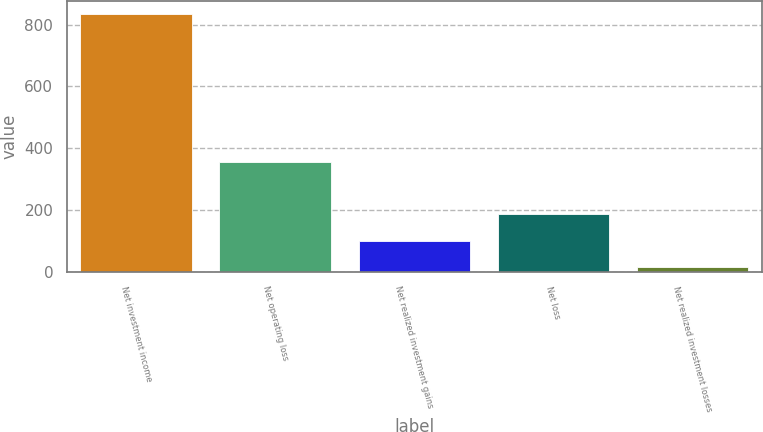Convert chart. <chart><loc_0><loc_0><loc_500><loc_500><bar_chart><fcel>Net investment income<fcel>Net operating loss<fcel>Net realized investment gains<fcel>Net loss<fcel>Net realized investment losses<nl><fcel>833<fcel>355<fcel>101.5<fcel>186<fcel>17<nl></chart> 